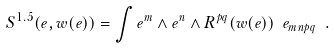Convert formula to latex. <formula><loc_0><loc_0><loc_500><loc_500>S ^ { 1 . 5 } ( e , w ( e ) ) = \int e ^ { m } \wedge e ^ { n } \wedge R ^ { p q } ( w ( e ) ) \ e _ { m n p q } \ .</formula> 